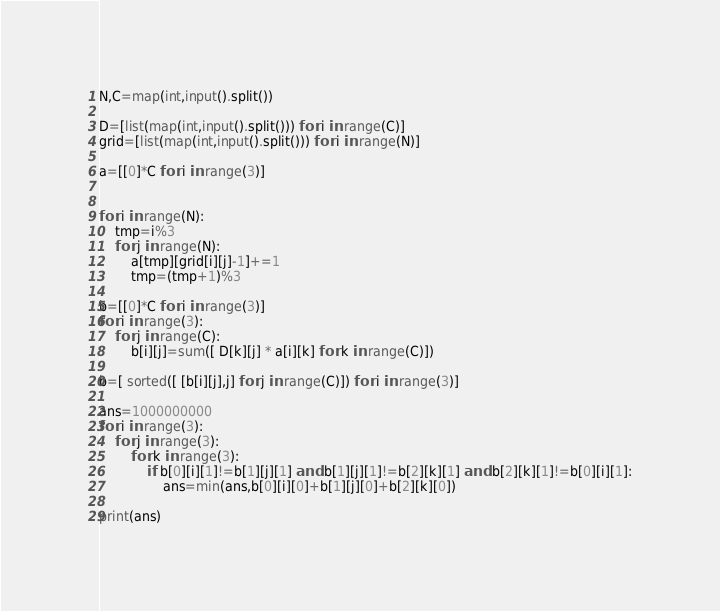Convert code to text. <code><loc_0><loc_0><loc_500><loc_500><_Python_>N,C=map(int,input().split())

D=[list(map(int,input().split())) for i in range(C)]
grid=[list(map(int,input().split())) for i in range(N)]

a=[[0]*C for i in range(3)]


for i in range(N):
    tmp=i%3
    for j in range(N):
        a[tmp][grid[i][j]-1]+=1
        tmp=(tmp+1)%3

b=[[0]*C for i in range(3)]
for i in range(3):
    for j in range(C):
        b[i][j]=sum([ D[k][j] * a[i][k] for k in range(C)])

b=[ sorted([ [b[i][j],j] for j in range(C)]) for i in range(3)]

ans=1000000000
for i in range(3):
    for j in range(3):
        for k in range(3):
            if b[0][i][1]!=b[1][j][1] and b[1][j][1]!=b[2][k][1] and b[2][k][1]!=b[0][i][1]:
                ans=min(ans,b[0][i][0]+b[1][j][0]+b[2][k][0])

print(ans)</code> 